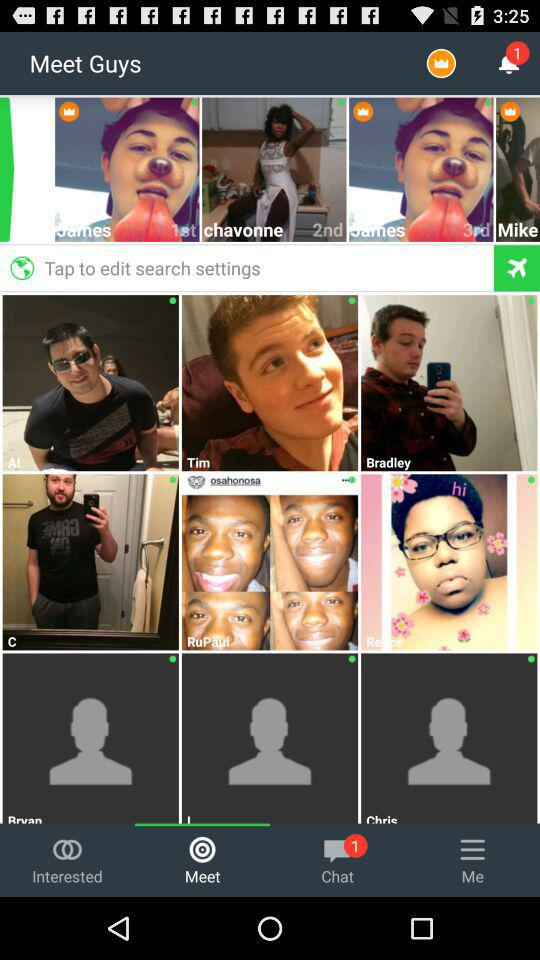Is there any unread notification?
When the provided information is insufficient, respond with <no answer>. <no answer> 